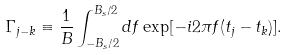<formula> <loc_0><loc_0><loc_500><loc_500>\Gamma _ { j - k } & \equiv \frac { 1 } { B } \int _ { - B _ { s } / 2 } ^ { B _ { s } / 2 } d f \exp [ - i 2 \pi f ( t _ { j } - t _ { k } ) ] .</formula> 